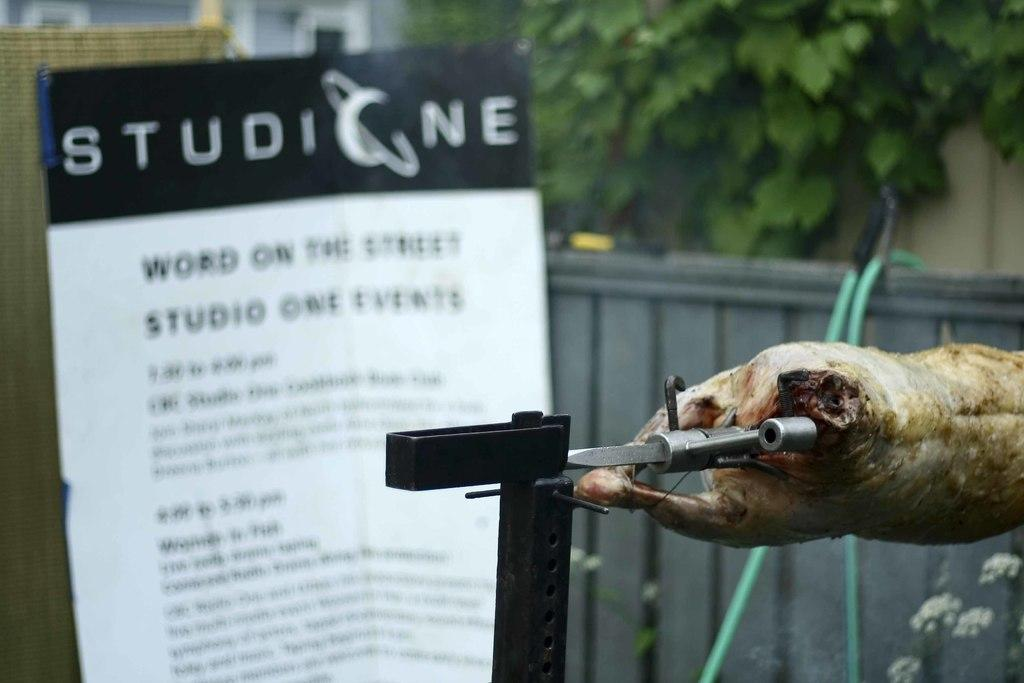What type of food is visible in the image? There is a meat of an animal in the image. What type of signage is present in the image? There is a hoarding in the image. What type of plant is visible in the image? There is a tree in the image. What type of structure is visible in the image? There is a wall in the image. How many buckets are hanging from the tree in the image? There are no buckets present in the image. Does the existence of the wall in the image prove the existence of a parallel universe? The presence of a wall in the image does not prove the existence of a parallel universe; it is simply a structure in the image. 